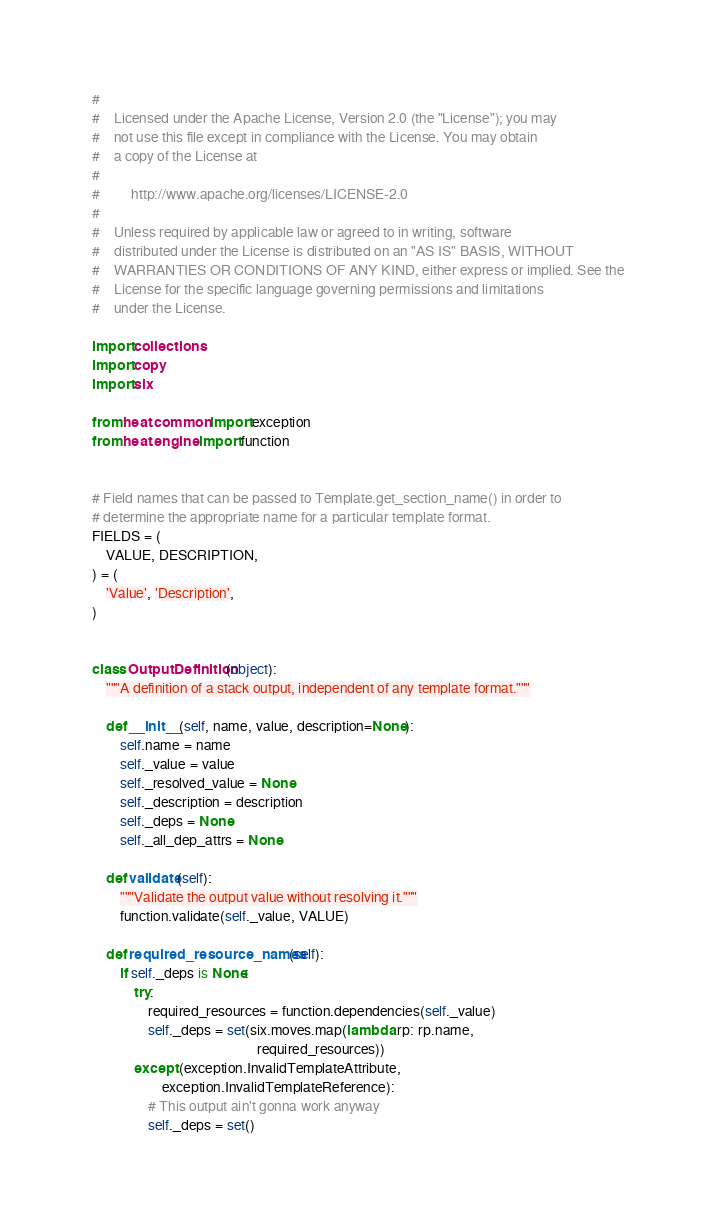<code> <loc_0><loc_0><loc_500><loc_500><_Python_>#
#    Licensed under the Apache License, Version 2.0 (the "License"); you may
#    not use this file except in compliance with the License. You may obtain
#    a copy of the License at
#
#         http://www.apache.org/licenses/LICENSE-2.0
#
#    Unless required by applicable law or agreed to in writing, software
#    distributed under the License is distributed on an "AS IS" BASIS, WITHOUT
#    WARRANTIES OR CONDITIONS OF ANY KIND, either express or implied. See the
#    License for the specific language governing permissions and limitations
#    under the License.

import collections
import copy
import six

from heat.common import exception
from heat.engine import function


# Field names that can be passed to Template.get_section_name() in order to
# determine the appropriate name for a particular template format.
FIELDS = (
    VALUE, DESCRIPTION,
) = (
    'Value', 'Description',
)


class OutputDefinition(object):
    """A definition of a stack output, independent of any template format."""

    def __init__(self, name, value, description=None):
        self.name = name
        self._value = value
        self._resolved_value = None
        self._description = description
        self._deps = None
        self._all_dep_attrs = None

    def validate(self):
        """Validate the output value without resolving it."""
        function.validate(self._value, VALUE)

    def required_resource_names(self):
        if self._deps is None:
            try:
                required_resources = function.dependencies(self._value)
                self._deps = set(six.moves.map(lambda rp: rp.name,
                                               required_resources))
            except (exception.InvalidTemplateAttribute,
                    exception.InvalidTemplateReference):
                # This output ain't gonna work anyway
                self._deps = set()</code> 